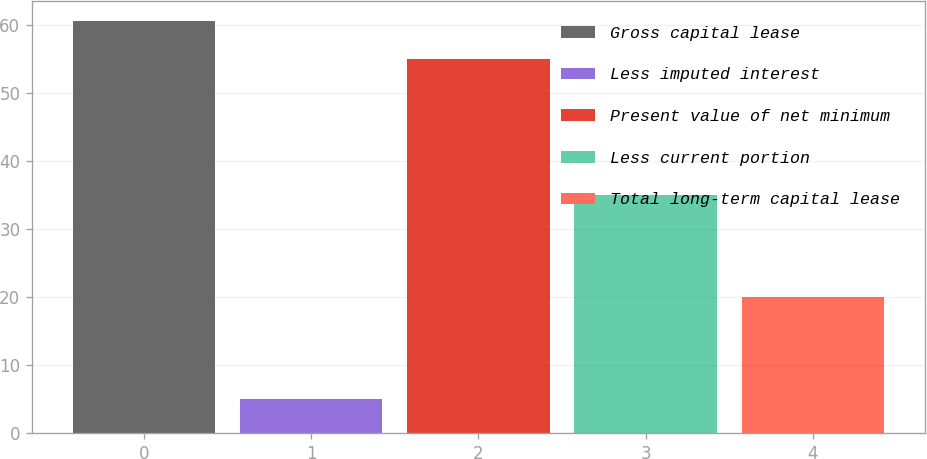Convert chart to OTSL. <chart><loc_0><loc_0><loc_500><loc_500><bar_chart><fcel>Gross capital lease<fcel>Less imputed interest<fcel>Present value of net minimum<fcel>Less current portion<fcel>Total long-term capital lease<nl><fcel>60.5<fcel>5<fcel>55<fcel>35<fcel>20<nl></chart> 